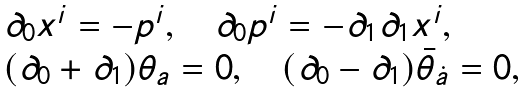<formula> <loc_0><loc_0><loc_500><loc_500>\begin{array} { l } \partial _ { 0 } x ^ { i } = - p ^ { i } , \quad \partial _ { 0 } p ^ { i } = - \partial _ { 1 } \partial _ { 1 } x ^ { i } , \\ ( \partial _ { 0 } + \partial _ { 1 } ) \theta _ { a } = 0 , \quad ( \partial _ { 0 } - \partial _ { 1 } ) \bar { \theta } _ { \dot { a } } = 0 , \end{array}</formula> 